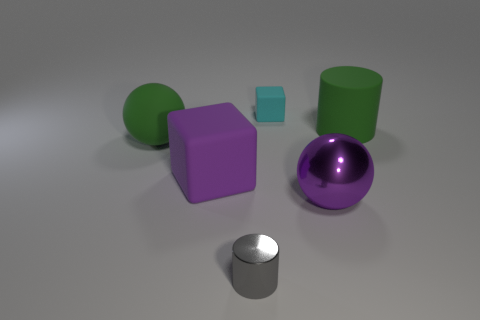Add 1 gray things. How many objects exist? 7 Subtract all small green rubber balls. Subtract all cyan objects. How many objects are left? 5 Add 1 small shiny objects. How many small shiny objects are left? 2 Add 1 rubber cubes. How many rubber cubes exist? 3 Subtract 0 green cubes. How many objects are left? 6 